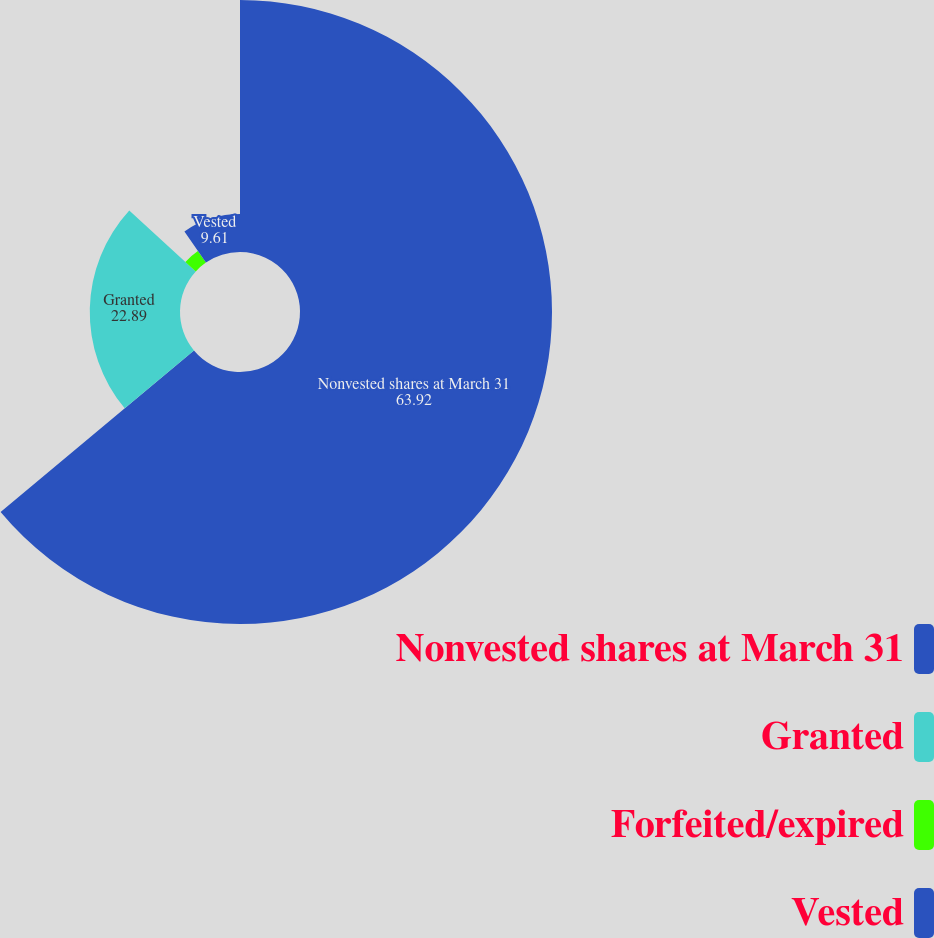<chart> <loc_0><loc_0><loc_500><loc_500><pie_chart><fcel>Nonvested shares at March 31<fcel>Granted<fcel>Forfeited/expired<fcel>Vested<nl><fcel>63.92%<fcel>22.89%<fcel>3.58%<fcel>9.61%<nl></chart> 